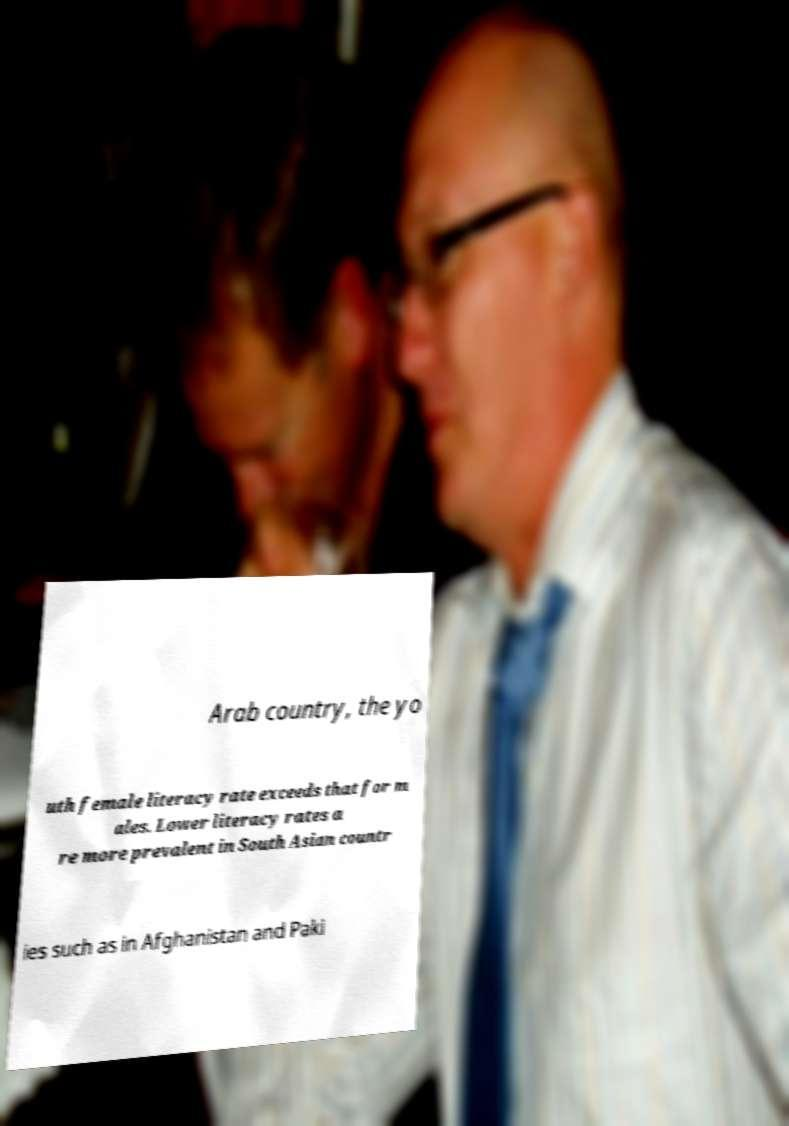Could you assist in decoding the text presented in this image and type it out clearly? Arab country, the yo uth female literacy rate exceeds that for m ales. Lower literacy rates a re more prevalent in South Asian countr ies such as in Afghanistan and Paki 